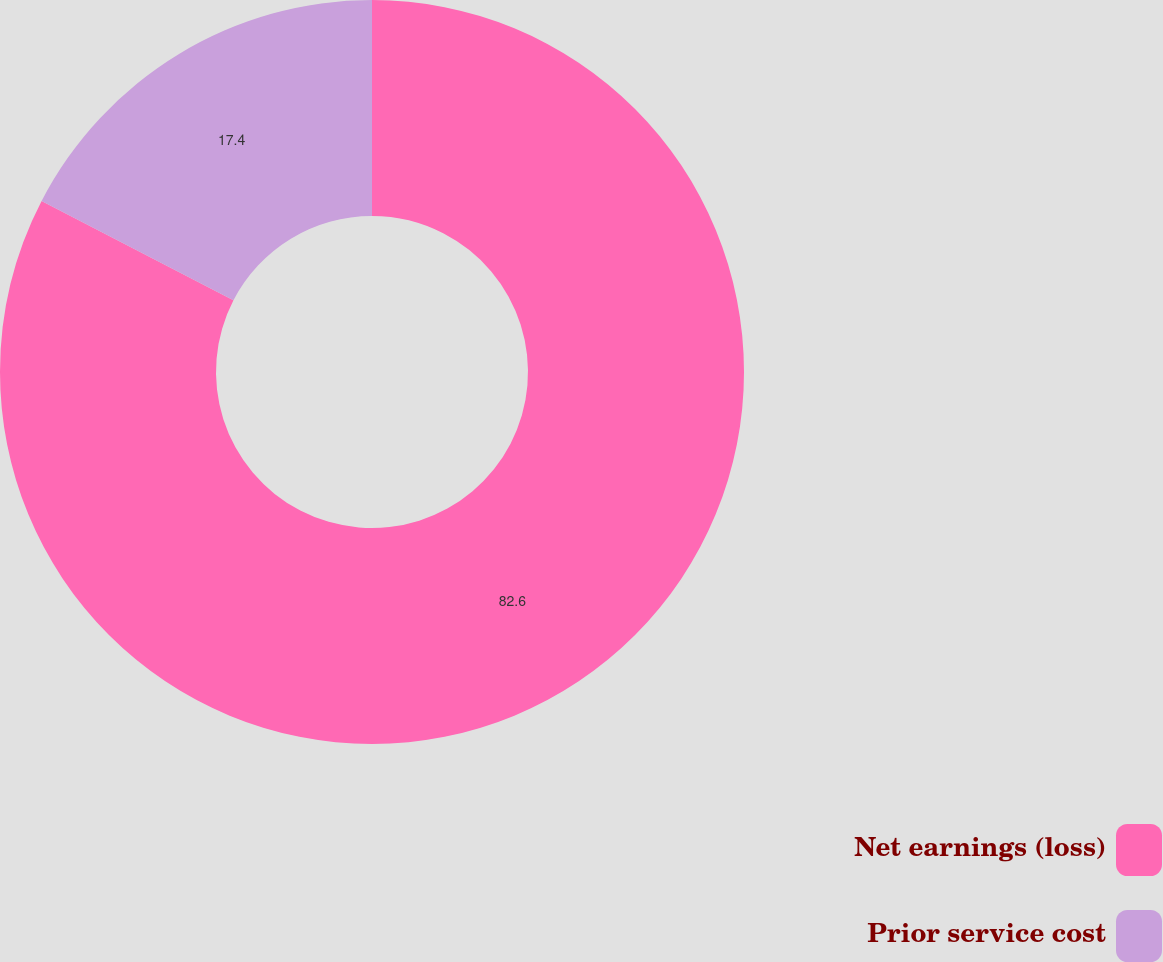Convert chart to OTSL. <chart><loc_0><loc_0><loc_500><loc_500><pie_chart><fcel>Net earnings (loss)<fcel>Prior service cost<nl><fcel>82.6%<fcel>17.4%<nl></chart> 